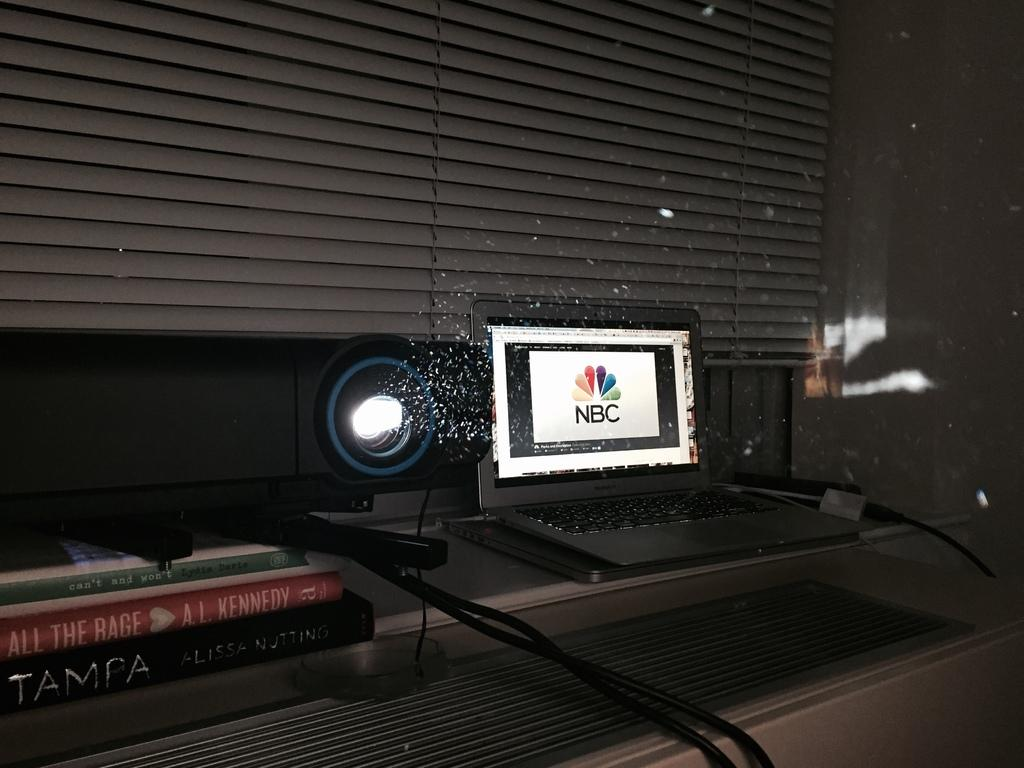<image>
Give a short and clear explanation of the subsequent image. A laptop has a NBC written on it as a part of the logo. 